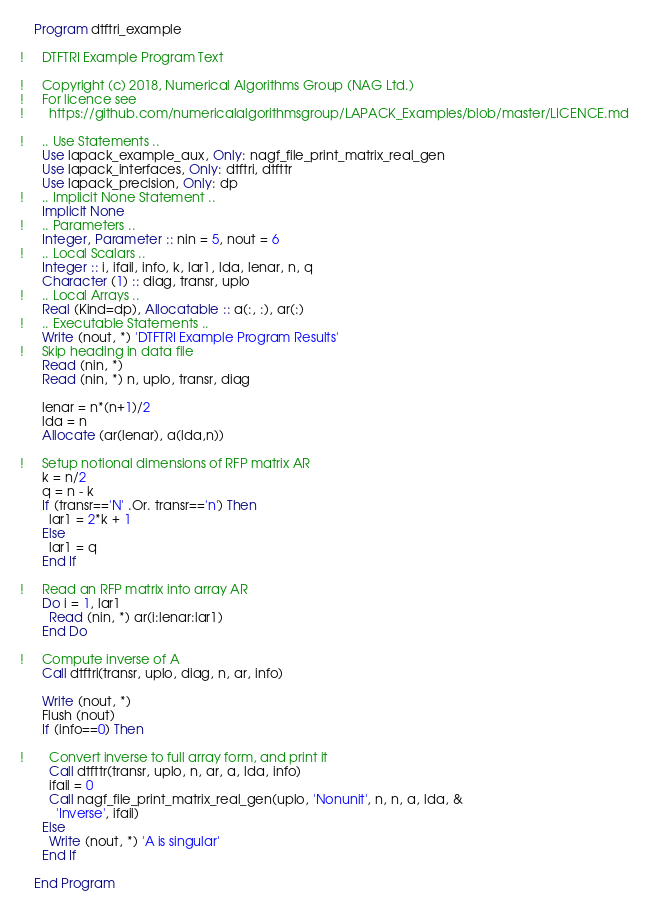<code> <loc_0><loc_0><loc_500><loc_500><_FORTRAN_>    Program dtftri_example

!     DTFTRI Example Program Text

!     Copyright (c) 2018, Numerical Algorithms Group (NAG Ltd.)
!     For licence see
!       https://github.com/numericalalgorithmsgroup/LAPACK_Examples/blob/master/LICENCE.md

!     .. Use Statements ..
      Use lapack_example_aux, Only: nagf_file_print_matrix_real_gen
      Use lapack_interfaces, Only: dtftri, dtfttr
      Use lapack_precision, Only: dp
!     .. Implicit None Statement ..
      Implicit None
!     .. Parameters ..
      Integer, Parameter :: nin = 5, nout = 6
!     .. Local Scalars ..
      Integer :: i, ifail, info, k, lar1, lda, lenar, n, q
      Character (1) :: diag, transr, uplo
!     .. Local Arrays ..
      Real (Kind=dp), Allocatable :: a(:, :), ar(:)
!     .. Executable Statements ..
      Write (nout, *) 'DTFTRI Example Program Results'
!     Skip heading in data file
      Read (nin, *)
      Read (nin, *) n, uplo, transr, diag

      lenar = n*(n+1)/2
      lda = n
      Allocate (ar(lenar), a(lda,n))

!     Setup notional dimensions of RFP matrix AR
      k = n/2
      q = n - k
      If (transr=='N' .Or. transr=='n') Then
        lar1 = 2*k + 1
      Else
        lar1 = q
      End If

!     Read an RFP matrix into array AR
      Do i = 1, lar1
        Read (nin, *) ar(i:lenar:lar1)
      End Do

!     Compute inverse of A
      Call dtftri(transr, uplo, diag, n, ar, info)

      Write (nout, *)
      Flush (nout)
      If (info==0) Then

!       Convert inverse to full array form, and print it
        Call dtfttr(transr, uplo, n, ar, a, lda, info)
        ifail = 0
        Call nagf_file_print_matrix_real_gen(uplo, 'Nonunit', n, n, a, lda, &
          'Inverse', ifail)
      Else
        Write (nout, *) 'A is singular'
      End If

    End Program
</code> 